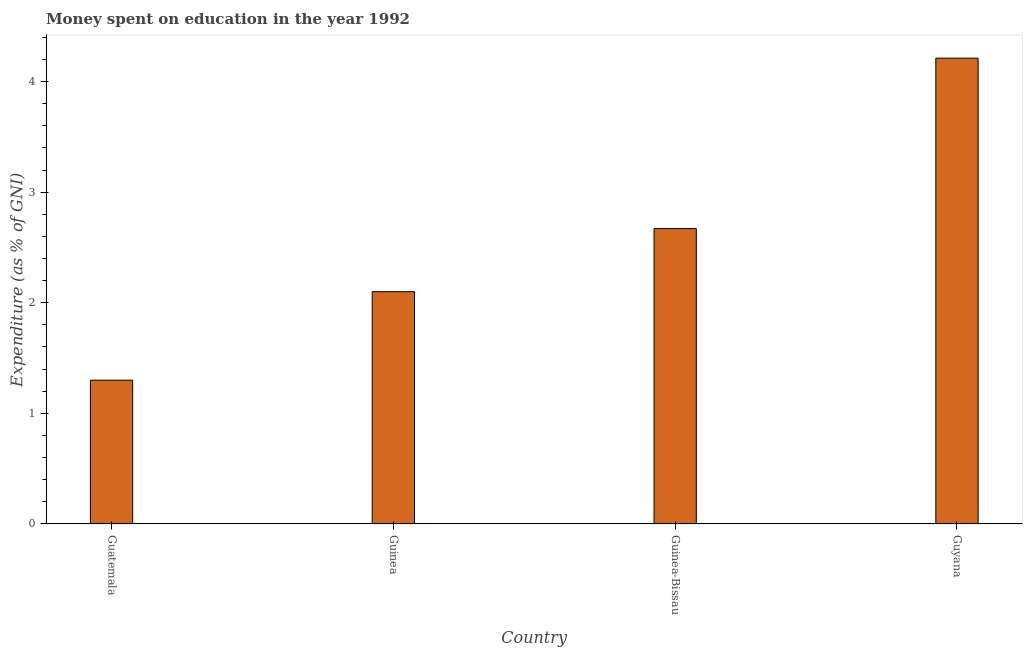What is the title of the graph?
Offer a very short reply. Money spent on education in the year 1992. What is the label or title of the X-axis?
Give a very brief answer. Country. What is the label or title of the Y-axis?
Your answer should be compact. Expenditure (as % of GNI). What is the expenditure on education in Guyana?
Offer a very short reply. 4.21. Across all countries, what is the maximum expenditure on education?
Ensure brevity in your answer.  4.21. In which country was the expenditure on education maximum?
Offer a very short reply. Guyana. In which country was the expenditure on education minimum?
Give a very brief answer. Guatemala. What is the sum of the expenditure on education?
Your answer should be compact. 10.28. What is the difference between the expenditure on education in Guinea and Guyana?
Keep it short and to the point. -2.11. What is the average expenditure on education per country?
Keep it short and to the point. 2.57. What is the median expenditure on education?
Your response must be concise. 2.39. What is the ratio of the expenditure on education in Guatemala to that in Guyana?
Give a very brief answer. 0.31. Is the expenditure on education in Guinea less than that in Guinea-Bissau?
Keep it short and to the point. Yes. What is the difference between the highest and the second highest expenditure on education?
Your answer should be very brief. 1.54. What is the difference between the highest and the lowest expenditure on education?
Your answer should be very brief. 2.91. In how many countries, is the expenditure on education greater than the average expenditure on education taken over all countries?
Keep it short and to the point. 2. How many bars are there?
Make the answer very short. 4. How many countries are there in the graph?
Your response must be concise. 4. Are the values on the major ticks of Y-axis written in scientific E-notation?
Provide a short and direct response. No. What is the Expenditure (as % of GNI) in Guatemala?
Provide a short and direct response. 1.3. What is the Expenditure (as % of GNI) in Guinea?
Offer a terse response. 2.1. What is the Expenditure (as % of GNI) of Guinea-Bissau?
Provide a short and direct response. 2.67. What is the Expenditure (as % of GNI) in Guyana?
Give a very brief answer. 4.21. What is the difference between the Expenditure (as % of GNI) in Guatemala and Guinea?
Keep it short and to the point. -0.8. What is the difference between the Expenditure (as % of GNI) in Guatemala and Guinea-Bissau?
Offer a terse response. -1.37. What is the difference between the Expenditure (as % of GNI) in Guatemala and Guyana?
Provide a short and direct response. -2.91. What is the difference between the Expenditure (as % of GNI) in Guinea and Guinea-Bissau?
Keep it short and to the point. -0.57. What is the difference between the Expenditure (as % of GNI) in Guinea and Guyana?
Your answer should be compact. -2.11. What is the difference between the Expenditure (as % of GNI) in Guinea-Bissau and Guyana?
Offer a very short reply. -1.54. What is the ratio of the Expenditure (as % of GNI) in Guatemala to that in Guinea?
Your answer should be very brief. 0.62. What is the ratio of the Expenditure (as % of GNI) in Guatemala to that in Guinea-Bissau?
Provide a short and direct response. 0.49. What is the ratio of the Expenditure (as % of GNI) in Guatemala to that in Guyana?
Offer a terse response. 0.31. What is the ratio of the Expenditure (as % of GNI) in Guinea to that in Guinea-Bissau?
Provide a succinct answer. 0.79. What is the ratio of the Expenditure (as % of GNI) in Guinea to that in Guyana?
Your answer should be compact. 0.5. What is the ratio of the Expenditure (as % of GNI) in Guinea-Bissau to that in Guyana?
Provide a succinct answer. 0.63. 